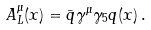<formula> <loc_0><loc_0><loc_500><loc_500>A _ { L } ^ { \mu } ( x ) = \bar { q } \gamma ^ { \mu } \gamma _ { 5 } { q } ( x ) \, .</formula> 